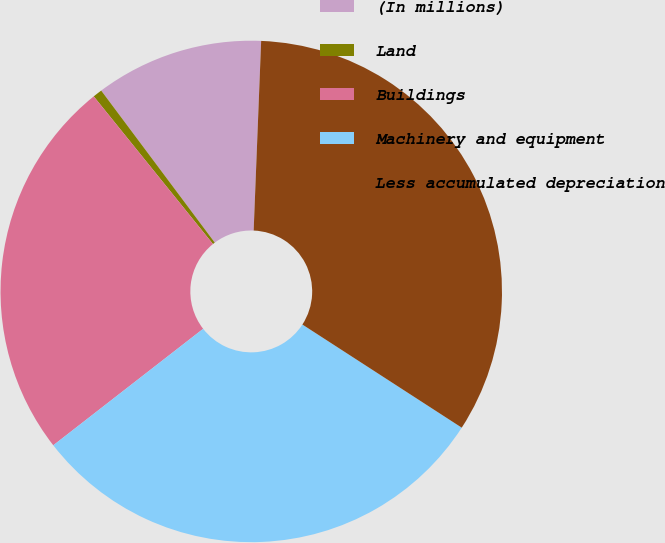<chart> <loc_0><loc_0><loc_500><loc_500><pie_chart><fcel>(In millions)<fcel>Land<fcel>Buildings<fcel>Machinery and equipment<fcel>Less accumulated depreciation<nl><fcel>10.84%<fcel>0.6%<fcel>24.7%<fcel>30.34%<fcel>33.51%<nl></chart> 